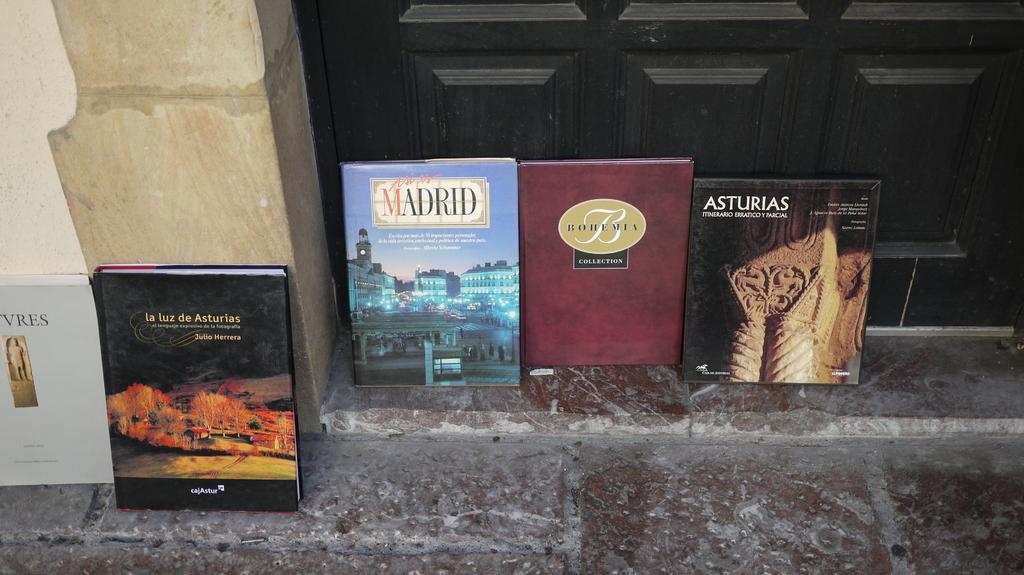<image>
Present a compact description of the photo's key features. Six books, one on Madrid, are lined up against the wall. 